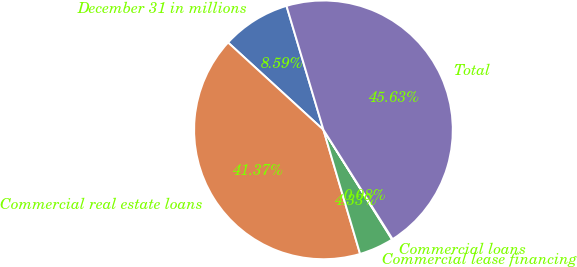Convert chart to OTSL. <chart><loc_0><loc_0><loc_500><loc_500><pie_chart><fcel>December 31 in millions<fcel>Commercial real estate loans<fcel>Commercial lease financing<fcel>Commercial loans<fcel>Total<nl><fcel>8.59%<fcel>41.37%<fcel>4.33%<fcel>0.08%<fcel>45.63%<nl></chart> 